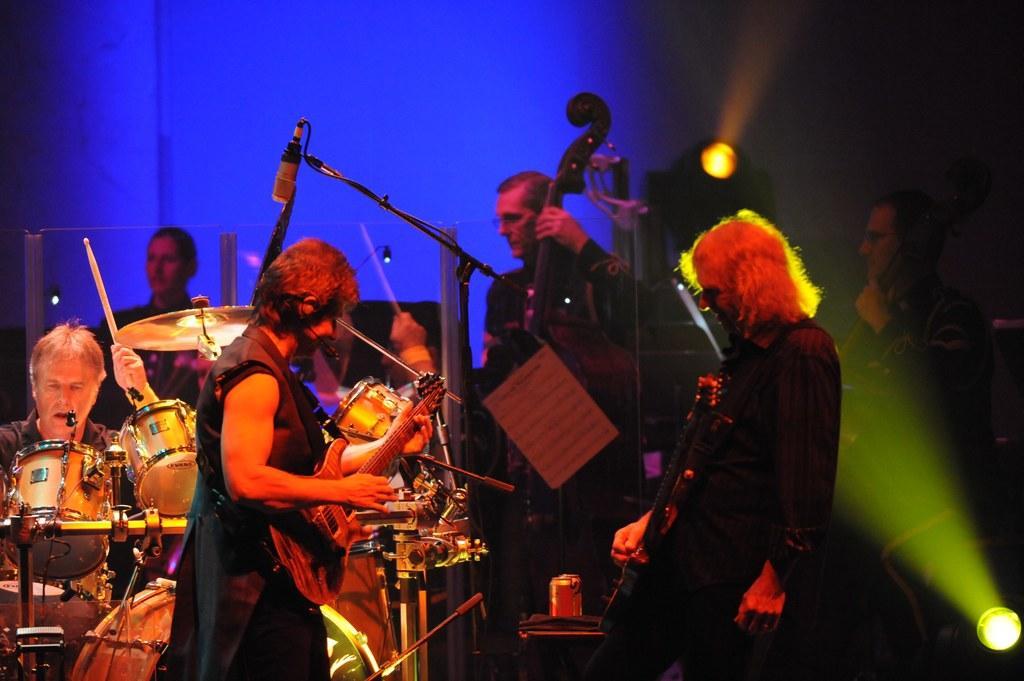Can you describe this image briefly? In the given image we can see there are many people with musical instruments. This are the lights. This is a microphone. This is a stick and can. 